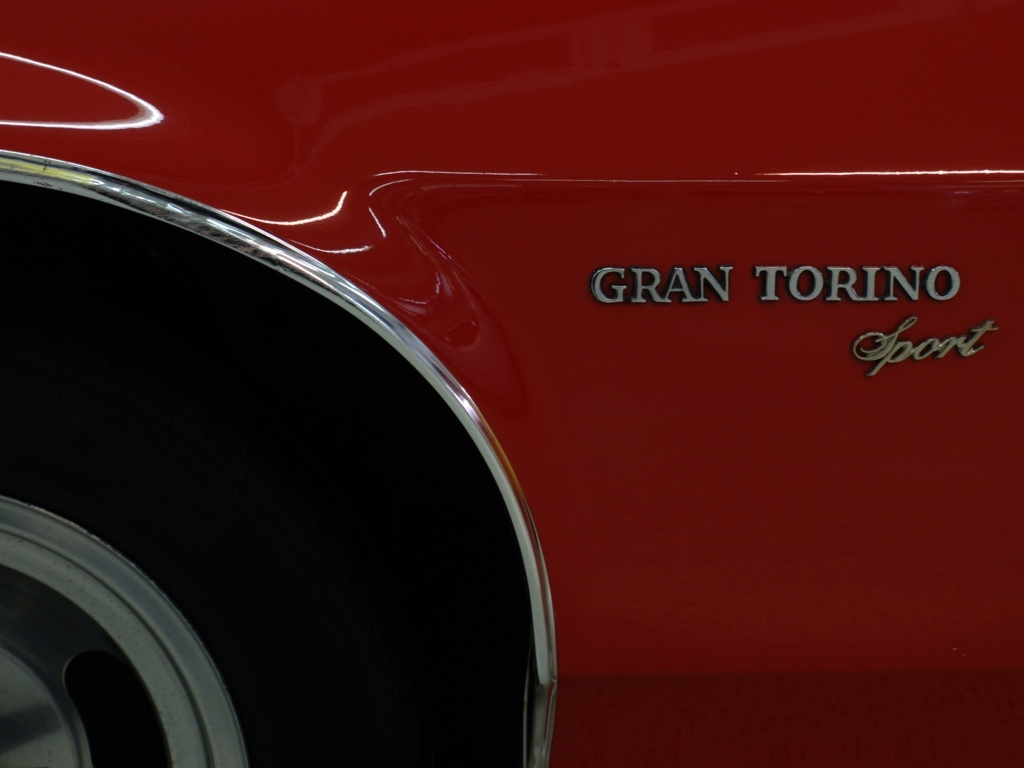Are the colors dull? Based on the image provided, the colors are vibrant and rich, particularly the red hue of the vehicle which is lustrous and deep, offering a sense of polish and well-maintained quality. The chrome detailing adds a contrasting brightness, contributing to the overall crisp appearance of the vehicle's aesthetics. Thus, the colors cannot be considered dull by any standard observation. 